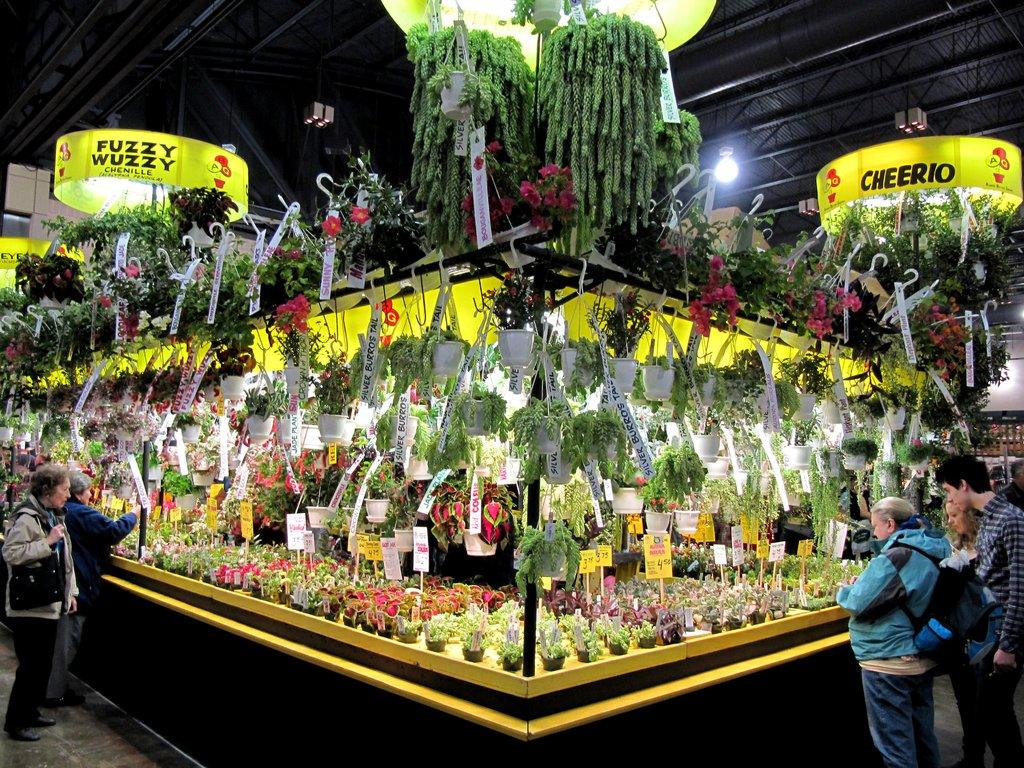What type of living organisms can be seen in the image? Plants can be seen in the image. How are the plants arranged in the image? The plants are placed in one area. What are the people near the plants doing? The people are standing beside the plants and watching them. What can be seen on the roof in the image? There are lights on the roof in the image. What type of game is being played by the plants in the image? There is no game being played by the plants in the image, as plants do not have the ability to play games. 